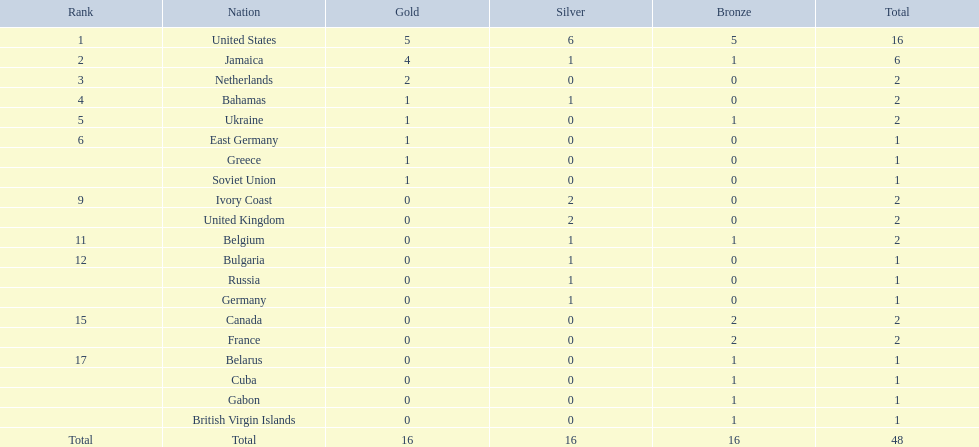Which nations took part? United States, Jamaica, Netherlands, Bahamas, Ukraine, East Germany, Greece, Soviet Union, Ivory Coast, United Kingdom, Belgium, Bulgaria, Russia, Germany, Canada, France, Belarus, Cuba, Gabon, British Virgin Islands. What was the gold medal count for each? 5, 4, 2, 1, 1, 1, 1, 1, 0, 0, 0, 0, 0, 0, 0, 0, 0, 0, 0, 0. And which nation secured the highest number? United States. 